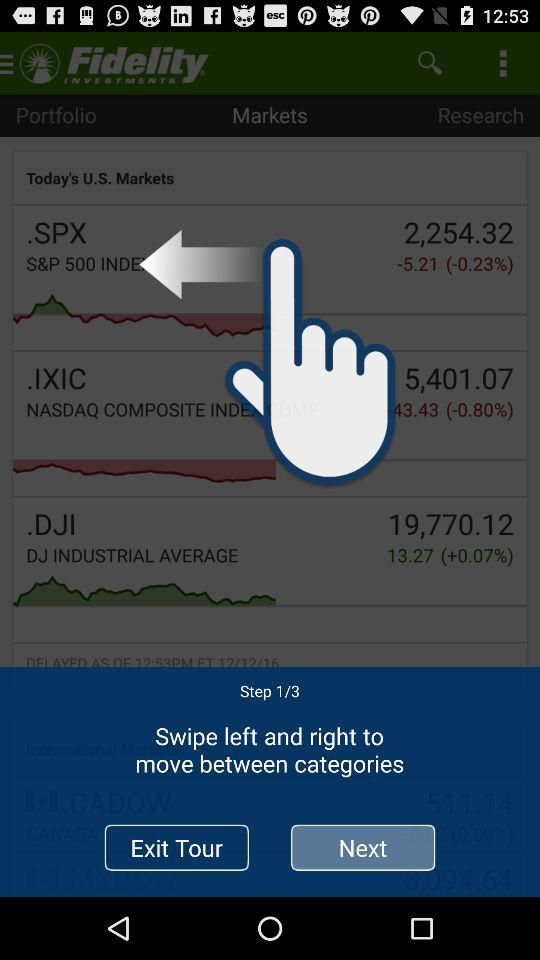How many steps are there? There are 3 steps. 